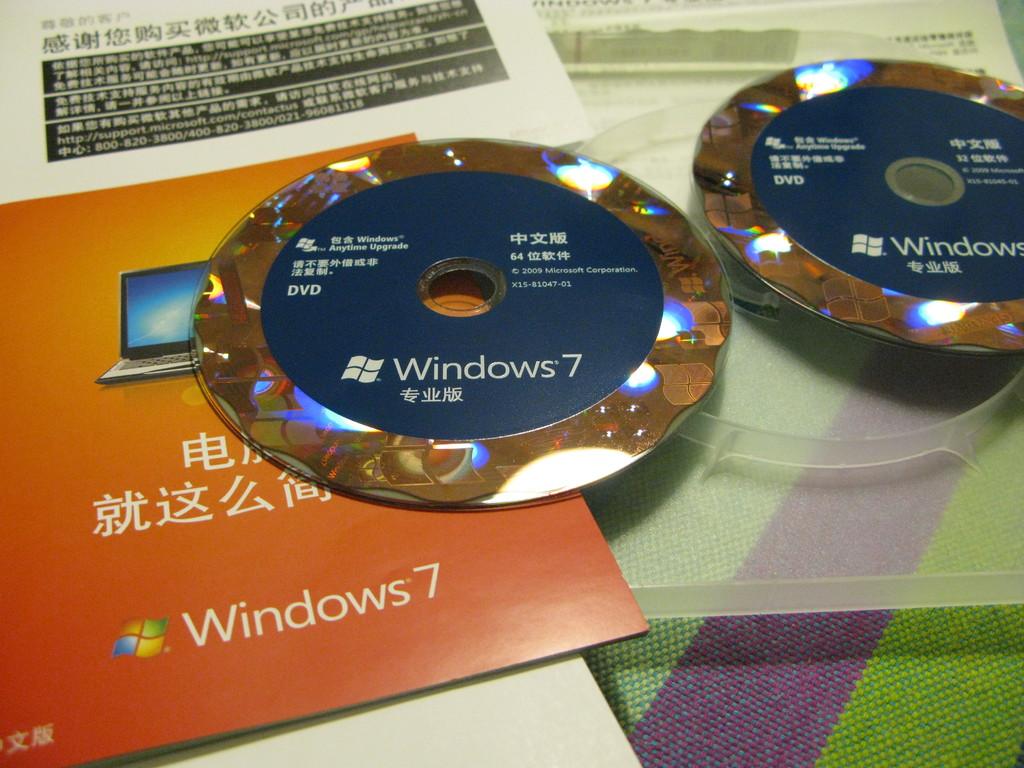Which windows version is this disc for?
Your answer should be very brief. 7. Which windows is that?
Make the answer very short. 7. 